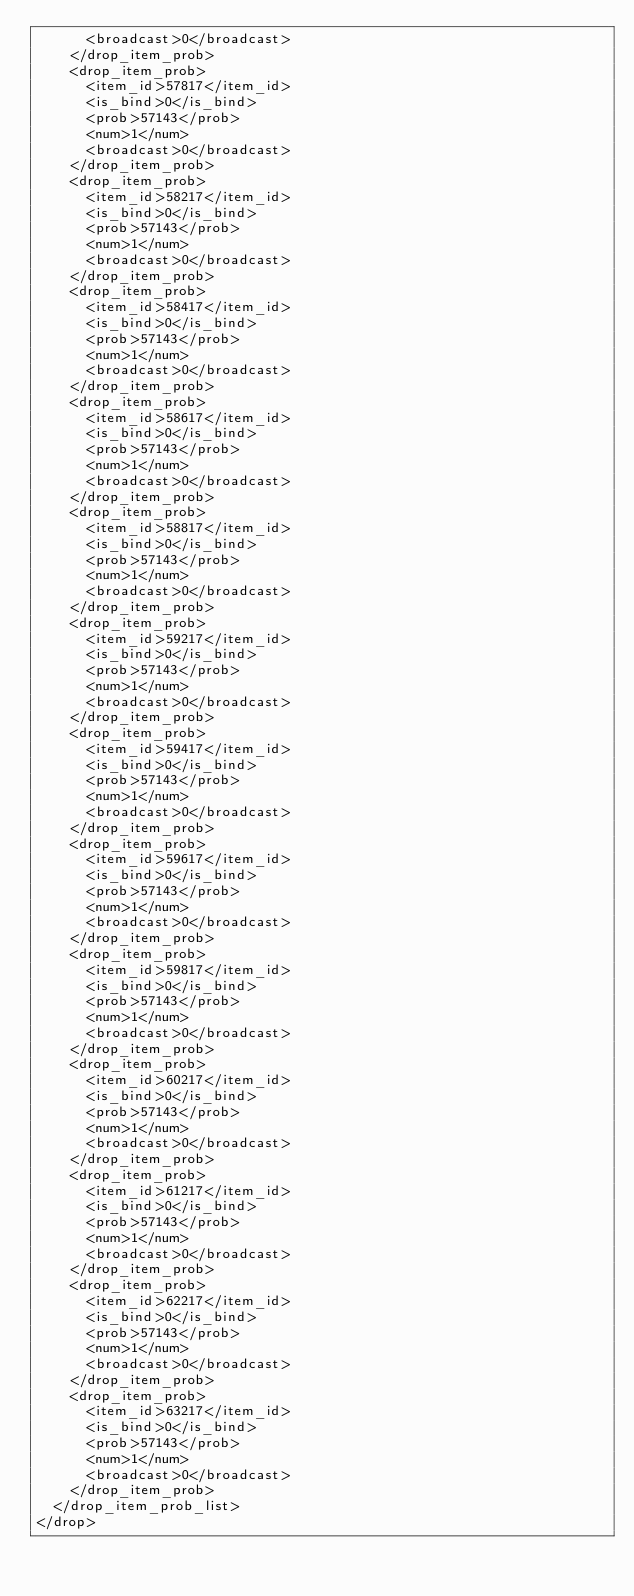Convert code to text. <code><loc_0><loc_0><loc_500><loc_500><_XML_>      <broadcast>0</broadcast>
    </drop_item_prob>
    <drop_item_prob>
      <item_id>57817</item_id>
      <is_bind>0</is_bind>
      <prob>57143</prob>
      <num>1</num>
      <broadcast>0</broadcast>
    </drop_item_prob>
    <drop_item_prob>
      <item_id>58217</item_id>
      <is_bind>0</is_bind>
      <prob>57143</prob>
      <num>1</num>
      <broadcast>0</broadcast>
    </drop_item_prob>
    <drop_item_prob>
      <item_id>58417</item_id>
      <is_bind>0</is_bind>
      <prob>57143</prob>
      <num>1</num>
      <broadcast>0</broadcast>
    </drop_item_prob>
    <drop_item_prob>
      <item_id>58617</item_id>
      <is_bind>0</is_bind>
      <prob>57143</prob>
      <num>1</num>
      <broadcast>0</broadcast>
    </drop_item_prob>
    <drop_item_prob>
      <item_id>58817</item_id>
      <is_bind>0</is_bind>
      <prob>57143</prob>
      <num>1</num>
      <broadcast>0</broadcast>
    </drop_item_prob>
    <drop_item_prob>
      <item_id>59217</item_id>
      <is_bind>0</is_bind>
      <prob>57143</prob>
      <num>1</num>
      <broadcast>0</broadcast>
    </drop_item_prob>
    <drop_item_prob>
      <item_id>59417</item_id>
      <is_bind>0</is_bind>
      <prob>57143</prob>
      <num>1</num>
      <broadcast>0</broadcast>
    </drop_item_prob>
    <drop_item_prob>
      <item_id>59617</item_id>
      <is_bind>0</is_bind>
      <prob>57143</prob>
      <num>1</num>
      <broadcast>0</broadcast>
    </drop_item_prob>
    <drop_item_prob>
      <item_id>59817</item_id>
      <is_bind>0</is_bind>
      <prob>57143</prob>
      <num>1</num>
      <broadcast>0</broadcast>
    </drop_item_prob>
    <drop_item_prob>
      <item_id>60217</item_id>
      <is_bind>0</is_bind>
      <prob>57143</prob>
      <num>1</num>
      <broadcast>0</broadcast>
    </drop_item_prob>
    <drop_item_prob>
      <item_id>61217</item_id>
      <is_bind>0</is_bind>
      <prob>57143</prob>
      <num>1</num>
      <broadcast>0</broadcast>
    </drop_item_prob>
    <drop_item_prob>
      <item_id>62217</item_id>
      <is_bind>0</is_bind>
      <prob>57143</prob>
      <num>1</num>
      <broadcast>0</broadcast>
    </drop_item_prob>
    <drop_item_prob>
      <item_id>63217</item_id>
      <is_bind>0</is_bind>
      <prob>57143</prob>
      <num>1</num>
      <broadcast>0</broadcast>
    </drop_item_prob>
  </drop_item_prob_list>
</drop>
</code> 